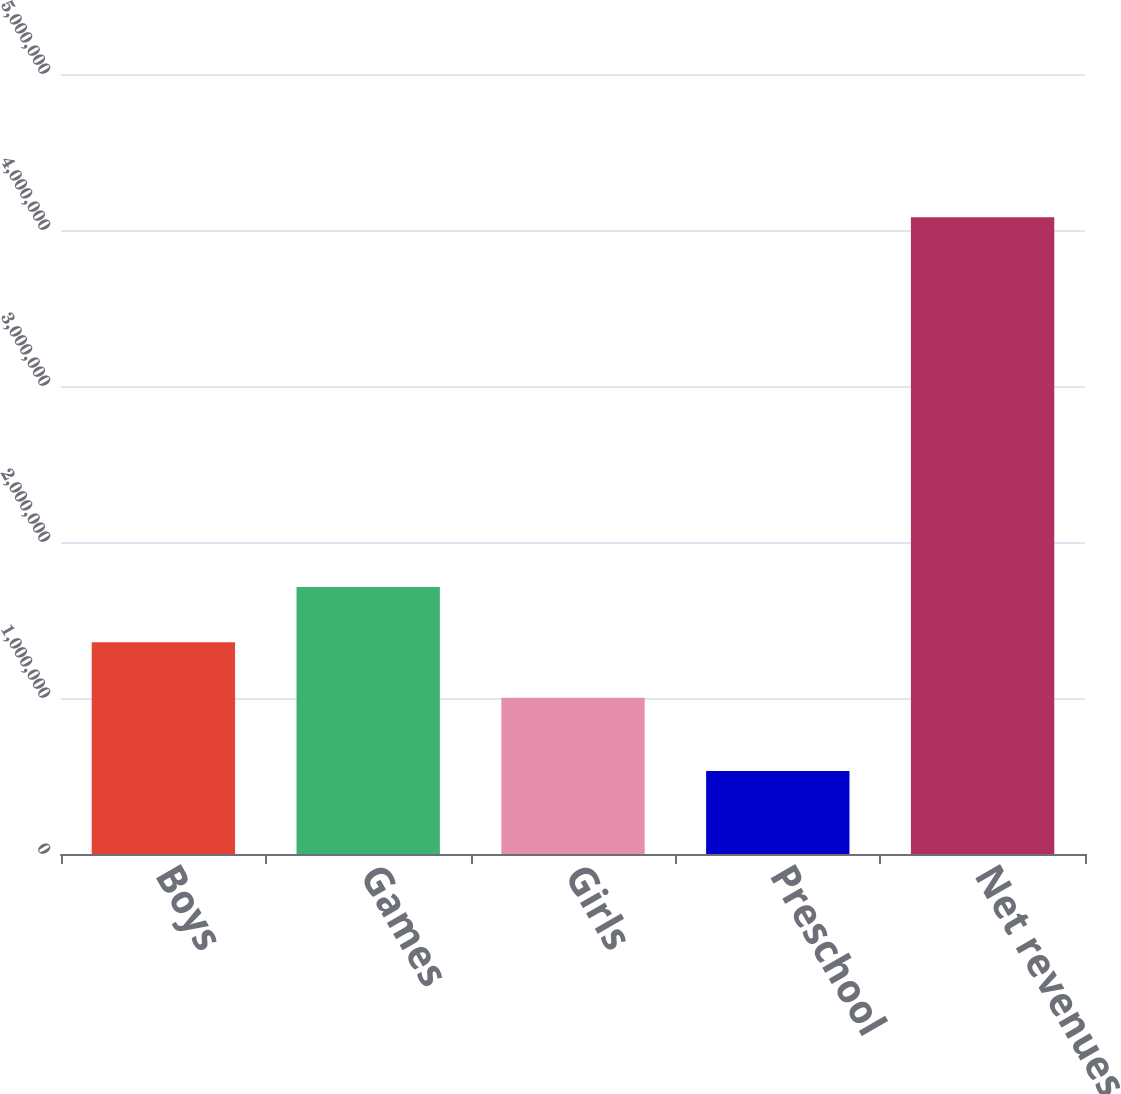<chart> <loc_0><loc_0><loc_500><loc_500><bar_chart><fcel>Boys<fcel>Games<fcel>Girls<fcel>Preschool<fcel>Net revenues<nl><fcel>1.35676e+06<fcel>1.71181e+06<fcel>1.0017e+06<fcel>531637<fcel>4.08216e+06<nl></chart> 